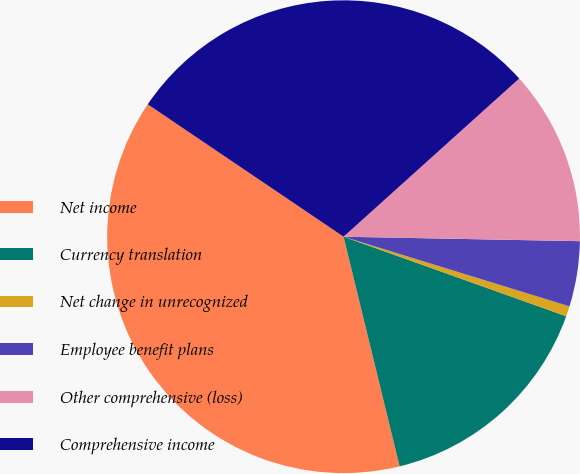Convert chart to OTSL. <chart><loc_0><loc_0><loc_500><loc_500><pie_chart><fcel>Net income<fcel>Currency translation<fcel>Net change in unrecognized<fcel>Employee benefit plans<fcel>Other comprehensive (loss)<fcel>Comprehensive income<nl><fcel>38.27%<fcel>15.73%<fcel>0.7%<fcel>4.46%<fcel>11.97%<fcel>28.87%<nl></chart> 